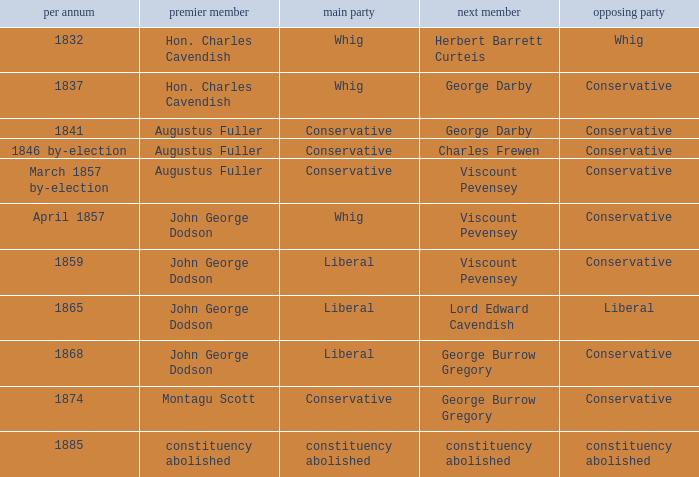In 1837, who was the 2nd member who's 2nd party was conservative. George Darby. 